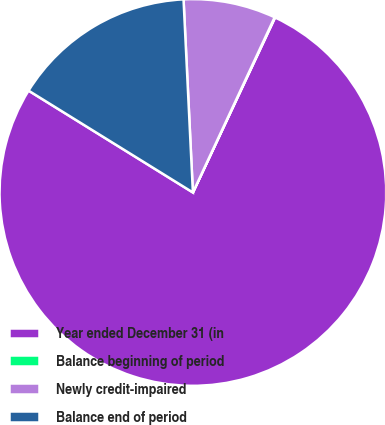Convert chart. <chart><loc_0><loc_0><loc_500><loc_500><pie_chart><fcel>Year ended December 31 (in<fcel>Balance beginning of period<fcel>Newly credit-impaired<fcel>Balance end of period<nl><fcel>76.84%<fcel>0.04%<fcel>7.72%<fcel>15.4%<nl></chart> 